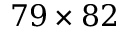Convert formula to latex. <formula><loc_0><loc_0><loc_500><loc_500>7 9 \times 8 2</formula> 